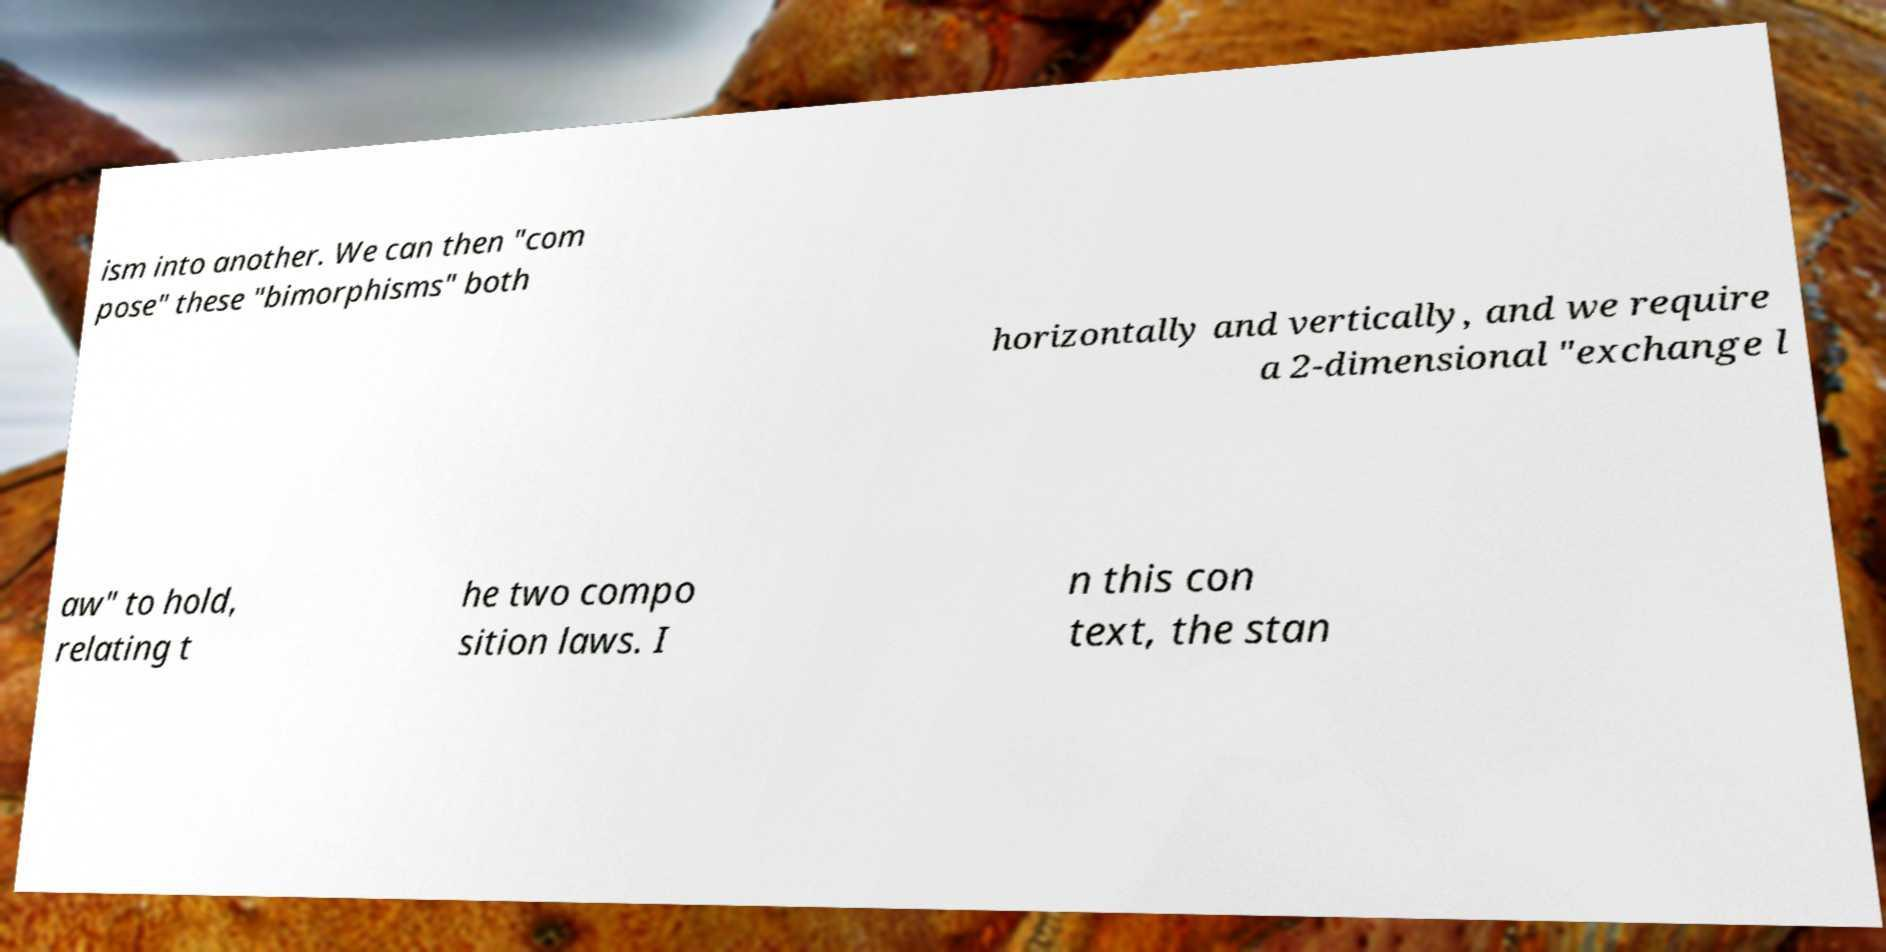For documentation purposes, I need the text within this image transcribed. Could you provide that? ism into another. We can then "com pose" these "bimorphisms" both horizontally and vertically, and we require a 2-dimensional "exchange l aw" to hold, relating t he two compo sition laws. I n this con text, the stan 